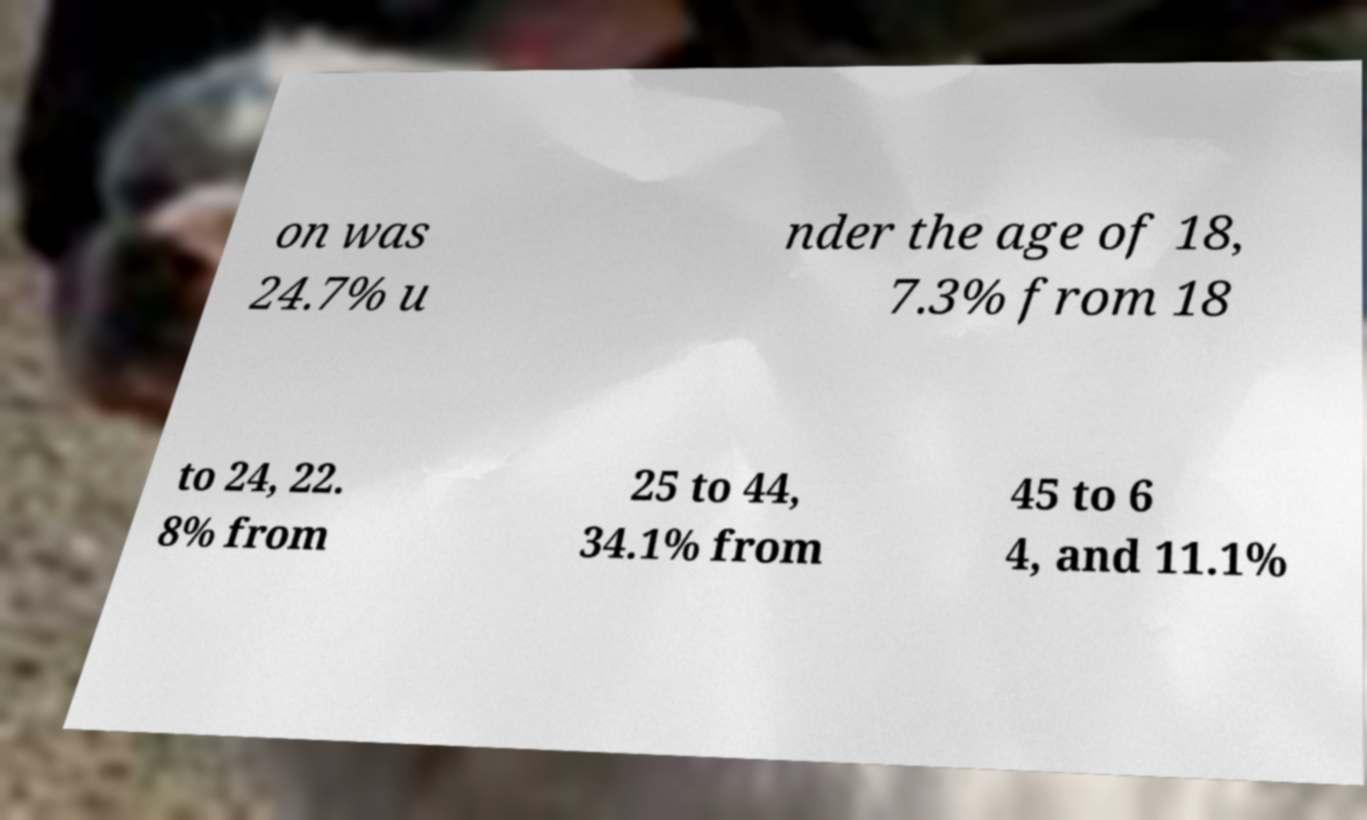Please identify and transcribe the text found in this image. on was 24.7% u nder the age of 18, 7.3% from 18 to 24, 22. 8% from 25 to 44, 34.1% from 45 to 6 4, and 11.1% 